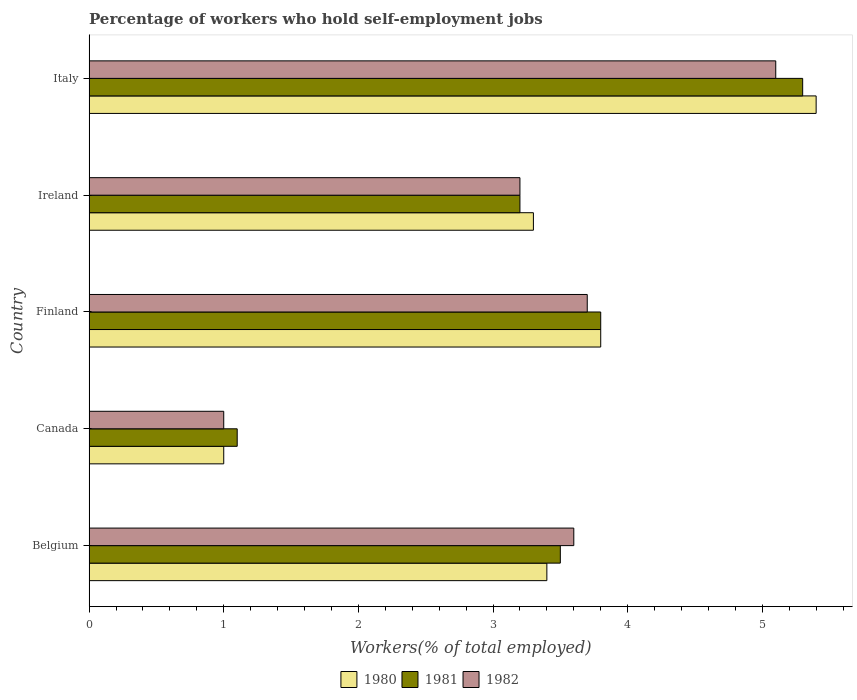How many groups of bars are there?
Ensure brevity in your answer.  5. Are the number of bars on each tick of the Y-axis equal?
Provide a short and direct response. Yes. What is the label of the 4th group of bars from the top?
Give a very brief answer. Canada. In how many cases, is the number of bars for a given country not equal to the number of legend labels?
Make the answer very short. 0. What is the percentage of self-employed workers in 1980 in Belgium?
Your answer should be very brief. 3.4. Across all countries, what is the maximum percentage of self-employed workers in 1982?
Provide a succinct answer. 5.1. Across all countries, what is the minimum percentage of self-employed workers in 1980?
Offer a terse response. 1. In which country was the percentage of self-employed workers in 1982 minimum?
Give a very brief answer. Canada. What is the total percentage of self-employed workers in 1981 in the graph?
Provide a short and direct response. 16.9. What is the difference between the percentage of self-employed workers in 1982 in Canada and that in Italy?
Provide a short and direct response. -4.1. What is the difference between the percentage of self-employed workers in 1982 in Ireland and the percentage of self-employed workers in 1981 in Finland?
Your response must be concise. -0.6. What is the average percentage of self-employed workers in 1982 per country?
Your response must be concise. 3.32. What is the difference between the percentage of self-employed workers in 1980 and percentage of self-employed workers in 1982 in Canada?
Keep it short and to the point. 0. What is the ratio of the percentage of self-employed workers in 1980 in Finland to that in Italy?
Offer a very short reply. 0.7. What is the difference between the highest and the second highest percentage of self-employed workers in 1982?
Offer a terse response. 1.4. What is the difference between the highest and the lowest percentage of self-employed workers in 1980?
Offer a terse response. 4.4. In how many countries, is the percentage of self-employed workers in 1981 greater than the average percentage of self-employed workers in 1981 taken over all countries?
Make the answer very short. 3. What does the 3rd bar from the top in Finland represents?
Offer a terse response. 1980. What does the 1st bar from the bottom in Italy represents?
Offer a very short reply. 1980. What is the difference between two consecutive major ticks on the X-axis?
Offer a terse response. 1. Does the graph contain any zero values?
Give a very brief answer. No. Where does the legend appear in the graph?
Keep it short and to the point. Bottom center. How many legend labels are there?
Give a very brief answer. 3. What is the title of the graph?
Your answer should be very brief. Percentage of workers who hold self-employment jobs. Does "1962" appear as one of the legend labels in the graph?
Provide a short and direct response. No. What is the label or title of the X-axis?
Provide a succinct answer. Workers(% of total employed). What is the Workers(% of total employed) in 1980 in Belgium?
Give a very brief answer. 3.4. What is the Workers(% of total employed) of 1981 in Belgium?
Make the answer very short. 3.5. What is the Workers(% of total employed) in 1982 in Belgium?
Your answer should be very brief. 3.6. What is the Workers(% of total employed) of 1980 in Canada?
Give a very brief answer. 1. What is the Workers(% of total employed) in 1981 in Canada?
Your answer should be compact. 1.1. What is the Workers(% of total employed) of 1982 in Canada?
Ensure brevity in your answer.  1. What is the Workers(% of total employed) of 1980 in Finland?
Keep it short and to the point. 3.8. What is the Workers(% of total employed) of 1981 in Finland?
Offer a very short reply. 3.8. What is the Workers(% of total employed) of 1982 in Finland?
Make the answer very short. 3.7. What is the Workers(% of total employed) of 1980 in Ireland?
Provide a short and direct response. 3.3. What is the Workers(% of total employed) of 1981 in Ireland?
Make the answer very short. 3.2. What is the Workers(% of total employed) of 1982 in Ireland?
Give a very brief answer. 3.2. What is the Workers(% of total employed) of 1980 in Italy?
Ensure brevity in your answer.  5.4. What is the Workers(% of total employed) of 1981 in Italy?
Provide a short and direct response. 5.3. What is the Workers(% of total employed) in 1982 in Italy?
Give a very brief answer. 5.1. Across all countries, what is the maximum Workers(% of total employed) in 1980?
Your answer should be compact. 5.4. Across all countries, what is the maximum Workers(% of total employed) of 1981?
Keep it short and to the point. 5.3. Across all countries, what is the maximum Workers(% of total employed) in 1982?
Give a very brief answer. 5.1. Across all countries, what is the minimum Workers(% of total employed) of 1981?
Your response must be concise. 1.1. Across all countries, what is the minimum Workers(% of total employed) in 1982?
Provide a succinct answer. 1. What is the difference between the Workers(% of total employed) in 1980 in Belgium and that in Canada?
Make the answer very short. 2.4. What is the difference between the Workers(% of total employed) of 1981 in Belgium and that in Finland?
Offer a very short reply. -0.3. What is the difference between the Workers(% of total employed) of 1980 in Belgium and that in Ireland?
Your answer should be compact. 0.1. What is the difference between the Workers(% of total employed) in 1982 in Belgium and that in Ireland?
Your answer should be compact. 0.4. What is the difference between the Workers(% of total employed) in 1980 in Belgium and that in Italy?
Your answer should be compact. -2. What is the difference between the Workers(% of total employed) in 1981 in Canada and that in Finland?
Offer a very short reply. -2.7. What is the difference between the Workers(% of total employed) in 1982 in Canada and that in Italy?
Ensure brevity in your answer.  -4.1. What is the difference between the Workers(% of total employed) of 1980 in Finland and that in Ireland?
Your response must be concise. 0.5. What is the difference between the Workers(% of total employed) in 1980 in Finland and that in Italy?
Your answer should be very brief. -1.6. What is the difference between the Workers(% of total employed) of 1982 in Finland and that in Italy?
Provide a succinct answer. -1.4. What is the difference between the Workers(% of total employed) of 1982 in Ireland and that in Italy?
Your answer should be compact. -1.9. What is the difference between the Workers(% of total employed) of 1980 in Belgium and the Workers(% of total employed) of 1982 in Canada?
Provide a short and direct response. 2.4. What is the difference between the Workers(% of total employed) in 1981 in Belgium and the Workers(% of total employed) in 1982 in Canada?
Your response must be concise. 2.5. What is the difference between the Workers(% of total employed) of 1980 in Belgium and the Workers(% of total employed) of 1981 in Finland?
Provide a short and direct response. -0.4. What is the difference between the Workers(% of total employed) in 1981 in Belgium and the Workers(% of total employed) in 1982 in Ireland?
Your response must be concise. 0.3. What is the difference between the Workers(% of total employed) in 1980 in Belgium and the Workers(% of total employed) in 1981 in Italy?
Ensure brevity in your answer.  -1.9. What is the difference between the Workers(% of total employed) of 1981 in Belgium and the Workers(% of total employed) of 1982 in Italy?
Provide a short and direct response. -1.6. What is the difference between the Workers(% of total employed) in 1980 in Canada and the Workers(% of total employed) in 1982 in Finland?
Give a very brief answer. -2.7. What is the difference between the Workers(% of total employed) of 1981 in Canada and the Workers(% of total employed) of 1982 in Ireland?
Your answer should be compact. -2.1. What is the difference between the Workers(% of total employed) of 1981 in Canada and the Workers(% of total employed) of 1982 in Italy?
Offer a terse response. -4. What is the difference between the Workers(% of total employed) of 1980 in Finland and the Workers(% of total employed) of 1981 in Ireland?
Your answer should be very brief. 0.6. What is the difference between the Workers(% of total employed) in 1981 in Finland and the Workers(% of total employed) in 1982 in Ireland?
Your answer should be compact. 0.6. What is the difference between the Workers(% of total employed) in 1980 in Finland and the Workers(% of total employed) in 1982 in Italy?
Your answer should be very brief. -1.3. What is the difference between the Workers(% of total employed) in 1981 in Finland and the Workers(% of total employed) in 1982 in Italy?
Provide a succinct answer. -1.3. What is the difference between the Workers(% of total employed) in 1980 in Ireland and the Workers(% of total employed) in 1981 in Italy?
Offer a very short reply. -2. What is the average Workers(% of total employed) in 1980 per country?
Make the answer very short. 3.38. What is the average Workers(% of total employed) in 1981 per country?
Make the answer very short. 3.38. What is the average Workers(% of total employed) of 1982 per country?
Your answer should be compact. 3.32. What is the difference between the Workers(% of total employed) in 1980 and Workers(% of total employed) in 1982 in Belgium?
Your answer should be very brief. -0.2. What is the difference between the Workers(% of total employed) in 1980 and Workers(% of total employed) in 1982 in Canada?
Provide a succinct answer. 0. What is the difference between the Workers(% of total employed) in 1980 and Workers(% of total employed) in 1982 in Ireland?
Keep it short and to the point. 0.1. What is the difference between the Workers(% of total employed) in 1981 and Workers(% of total employed) in 1982 in Ireland?
Ensure brevity in your answer.  0. What is the difference between the Workers(% of total employed) of 1980 and Workers(% of total employed) of 1981 in Italy?
Keep it short and to the point. 0.1. What is the difference between the Workers(% of total employed) in 1980 and Workers(% of total employed) in 1982 in Italy?
Your answer should be very brief. 0.3. What is the difference between the Workers(% of total employed) of 1981 and Workers(% of total employed) of 1982 in Italy?
Keep it short and to the point. 0.2. What is the ratio of the Workers(% of total employed) in 1980 in Belgium to that in Canada?
Provide a short and direct response. 3.4. What is the ratio of the Workers(% of total employed) of 1981 in Belgium to that in Canada?
Provide a succinct answer. 3.18. What is the ratio of the Workers(% of total employed) in 1982 in Belgium to that in Canada?
Your answer should be compact. 3.6. What is the ratio of the Workers(% of total employed) in 1980 in Belgium to that in Finland?
Keep it short and to the point. 0.89. What is the ratio of the Workers(% of total employed) in 1981 in Belgium to that in Finland?
Your answer should be very brief. 0.92. What is the ratio of the Workers(% of total employed) of 1982 in Belgium to that in Finland?
Keep it short and to the point. 0.97. What is the ratio of the Workers(% of total employed) in 1980 in Belgium to that in Ireland?
Offer a very short reply. 1.03. What is the ratio of the Workers(% of total employed) in 1981 in Belgium to that in Ireland?
Make the answer very short. 1.09. What is the ratio of the Workers(% of total employed) of 1980 in Belgium to that in Italy?
Provide a succinct answer. 0.63. What is the ratio of the Workers(% of total employed) in 1981 in Belgium to that in Italy?
Keep it short and to the point. 0.66. What is the ratio of the Workers(% of total employed) of 1982 in Belgium to that in Italy?
Keep it short and to the point. 0.71. What is the ratio of the Workers(% of total employed) of 1980 in Canada to that in Finland?
Your answer should be compact. 0.26. What is the ratio of the Workers(% of total employed) of 1981 in Canada to that in Finland?
Ensure brevity in your answer.  0.29. What is the ratio of the Workers(% of total employed) in 1982 in Canada to that in Finland?
Offer a very short reply. 0.27. What is the ratio of the Workers(% of total employed) in 1980 in Canada to that in Ireland?
Ensure brevity in your answer.  0.3. What is the ratio of the Workers(% of total employed) in 1981 in Canada to that in Ireland?
Provide a short and direct response. 0.34. What is the ratio of the Workers(% of total employed) of 1982 in Canada to that in Ireland?
Give a very brief answer. 0.31. What is the ratio of the Workers(% of total employed) of 1980 in Canada to that in Italy?
Make the answer very short. 0.19. What is the ratio of the Workers(% of total employed) of 1981 in Canada to that in Italy?
Provide a succinct answer. 0.21. What is the ratio of the Workers(% of total employed) of 1982 in Canada to that in Italy?
Ensure brevity in your answer.  0.2. What is the ratio of the Workers(% of total employed) of 1980 in Finland to that in Ireland?
Give a very brief answer. 1.15. What is the ratio of the Workers(% of total employed) of 1981 in Finland to that in Ireland?
Make the answer very short. 1.19. What is the ratio of the Workers(% of total employed) of 1982 in Finland to that in Ireland?
Offer a terse response. 1.16. What is the ratio of the Workers(% of total employed) in 1980 in Finland to that in Italy?
Your response must be concise. 0.7. What is the ratio of the Workers(% of total employed) of 1981 in Finland to that in Italy?
Your answer should be compact. 0.72. What is the ratio of the Workers(% of total employed) in 1982 in Finland to that in Italy?
Offer a terse response. 0.73. What is the ratio of the Workers(% of total employed) of 1980 in Ireland to that in Italy?
Ensure brevity in your answer.  0.61. What is the ratio of the Workers(% of total employed) of 1981 in Ireland to that in Italy?
Your response must be concise. 0.6. What is the ratio of the Workers(% of total employed) in 1982 in Ireland to that in Italy?
Provide a short and direct response. 0.63. What is the difference between the highest and the second highest Workers(% of total employed) in 1980?
Provide a succinct answer. 1.6. What is the difference between the highest and the second highest Workers(% of total employed) in 1981?
Your response must be concise. 1.5. What is the difference between the highest and the second highest Workers(% of total employed) of 1982?
Keep it short and to the point. 1.4. What is the difference between the highest and the lowest Workers(% of total employed) of 1980?
Offer a terse response. 4.4. What is the difference between the highest and the lowest Workers(% of total employed) of 1981?
Your answer should be compact. 4.2. 